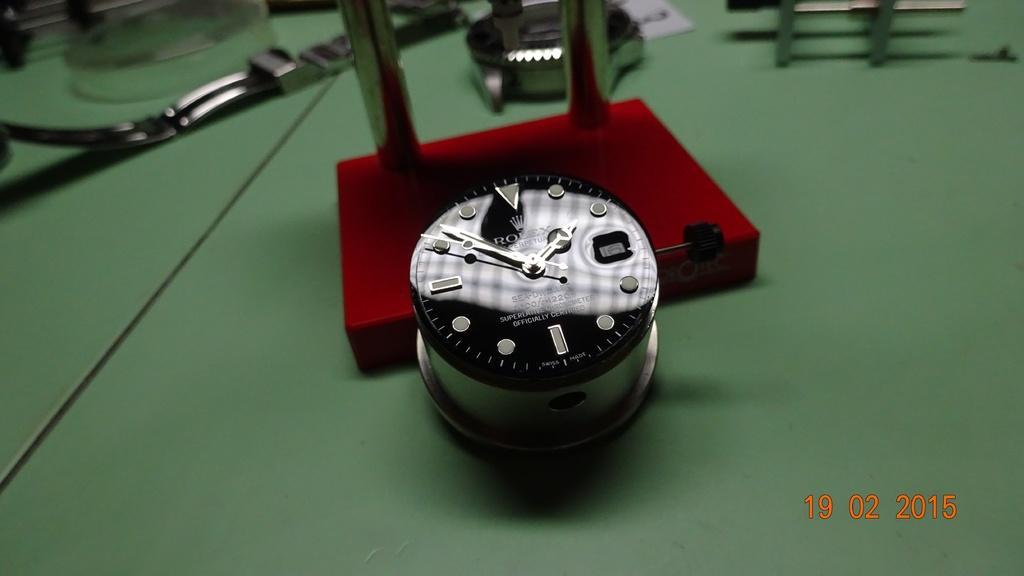Can you describe this image briefly? Here in this picture we can see a watch dial present on the table over there and we can also see other equipments like the straps of watch and shell of the watch and glass and other things present on it over there. 